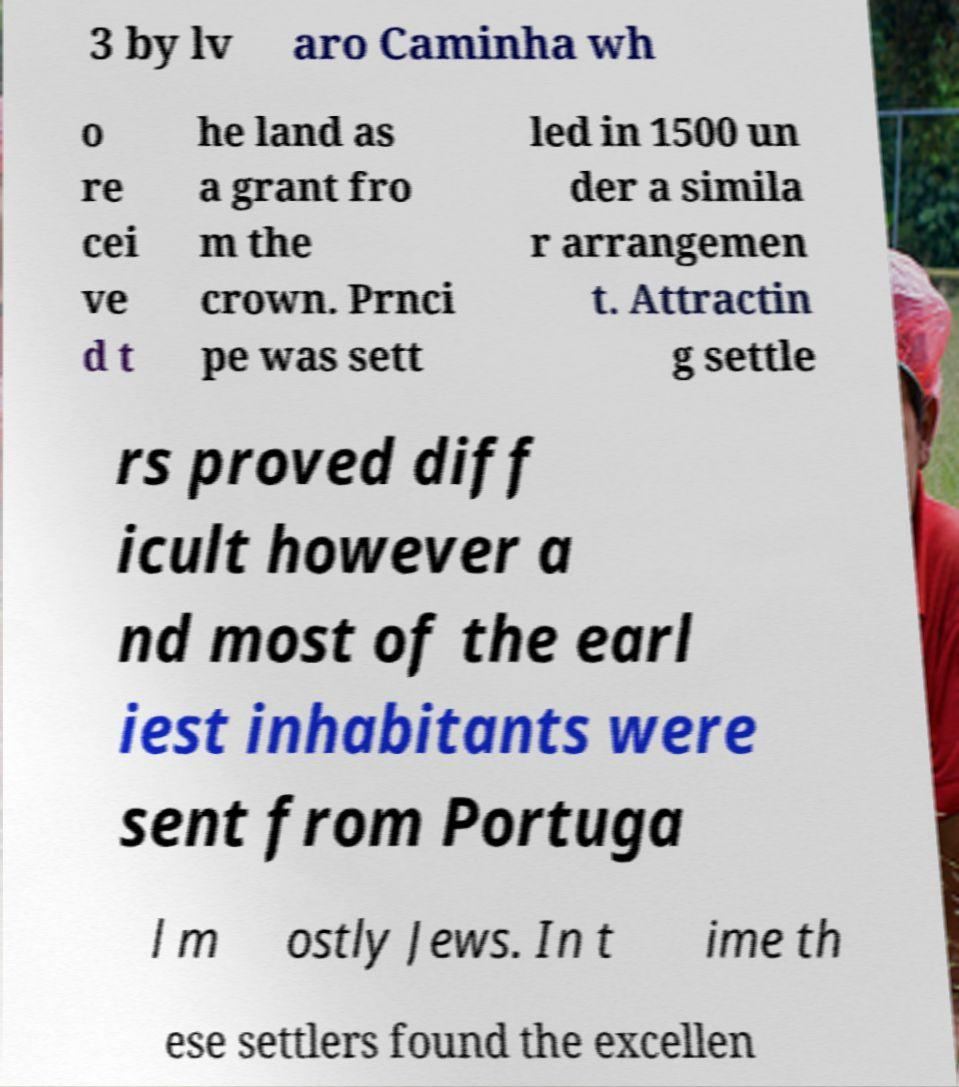Please read and relay the text visible in this image. What does it say? 3 by lv aro Caminha wh o re cei ve d t he land as a grant fro m the crown. Prnci pe was sett led in 1500 un der a simila r arrangemen t. Attractin g settle rs proved diff icult however a nd most of the earl iest inhabitants were sent from Portuga l m ostly Jews. In t ime th ese settlers found the excellen 